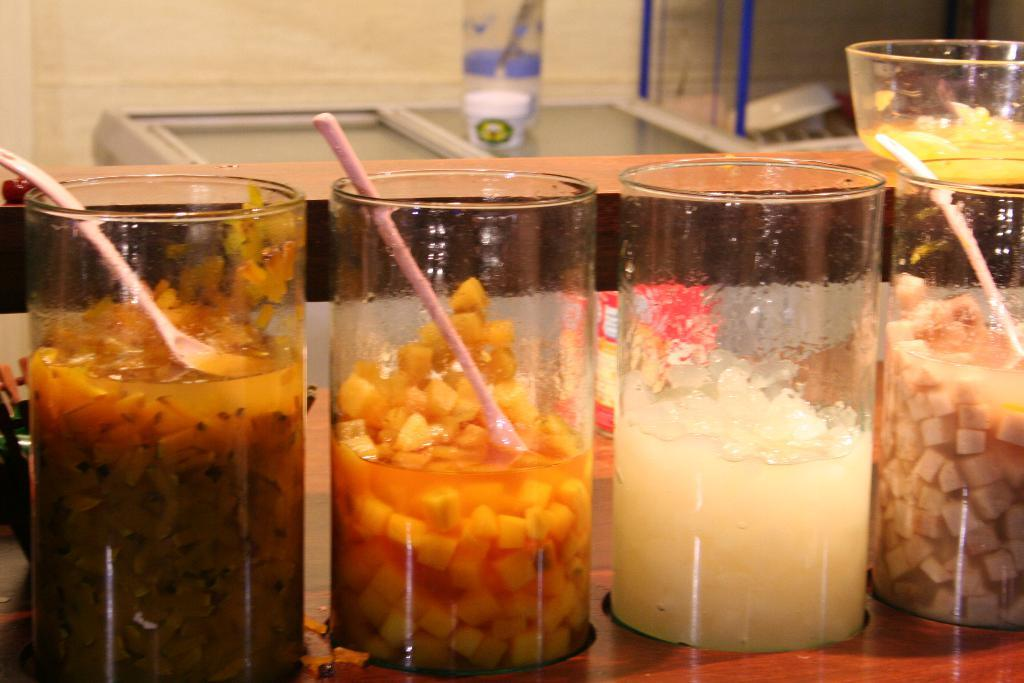What type of furniture is present in the image? There are tables in the image. What objects are placed on the tables? There are glasses on the tables. What can be found inside the glasses? There are food items and spoons in the glasses. What appliance can be seen in the background? There is a fridge in the background. What is on top of the fridge? There is a bottle on the fridge. How do the bears feel about the food items in the glasses? There are no bears present in the image, so it is not possible to determine how they might feel about the food items. 